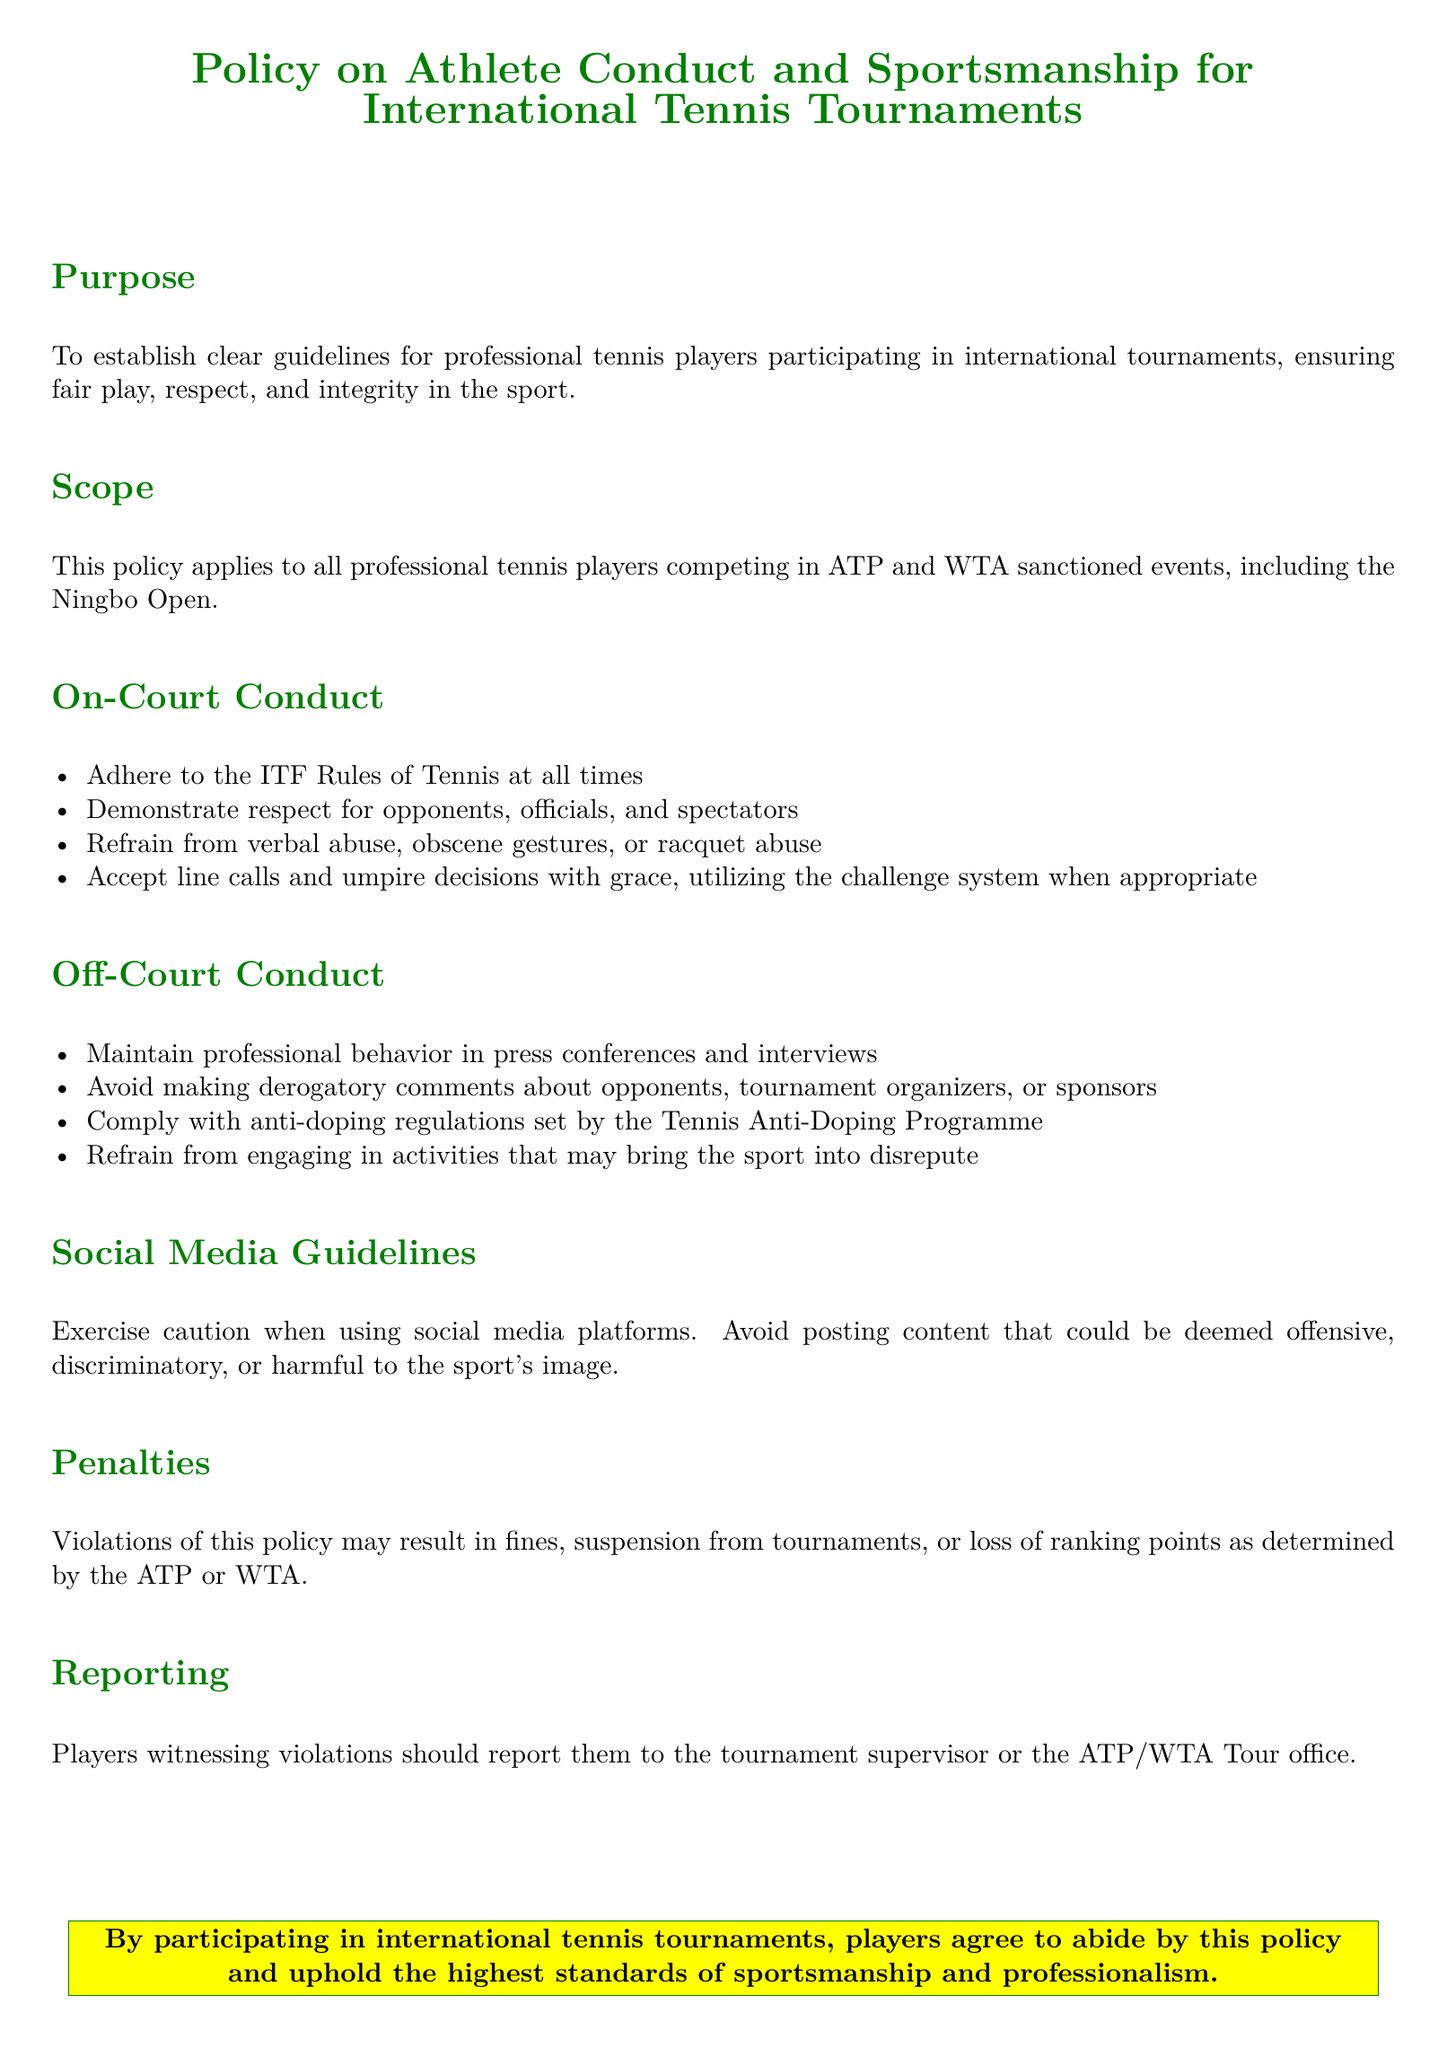What is the purpose of the policy? The purpose of the policy is to establish clear guidelines for professional tennis players participating in international tournaments, ensuring fair play, respect, and integrity in the sport.
Answer: Establish clear guidelines Who does this policy apply to? The policy applies to all professional tennis players competing in ATP and WTA sanctioned events, including the Ningbo Open.
Answer: All professional tennis players What should players refrain from during matches? Players should refrain from verbal abuse, obscene gestures, or racquet abuse during matches.
Answer: Verbal abuse, obscene gestures, racquet abuse What system should players utilize when disputing calls? Players should utilize the challenge system when disputing calls on court.
Answer: Challenge system What is the consequence for violating the policy? Violations of this policy may result in fines, suspension from tournaments, or loss of ranking points.
Answer: Fines, suspension, loss of ranking points What type of behavior should players maintain in press conferences? Players should maintain professional behavior in press conferences and interviews.
Answer: Professional behavior What is advised regarding social media content? Players are advised to avoid posting content that could be deemed offensive, discriminatory, or harmful to the sport's image.
Answer: Avoid offensive content Who should players report violations to? Players witnessing violations should report them to the tournament supervisor or the ATP/WTA Tour office.
Answer: Tournament supervisor or ATP/WTA Tour office What is the color of the box surrounding the agreement statement? The color of the box surrounding the agreement statement is tennis green.
Answer: Tennis green 